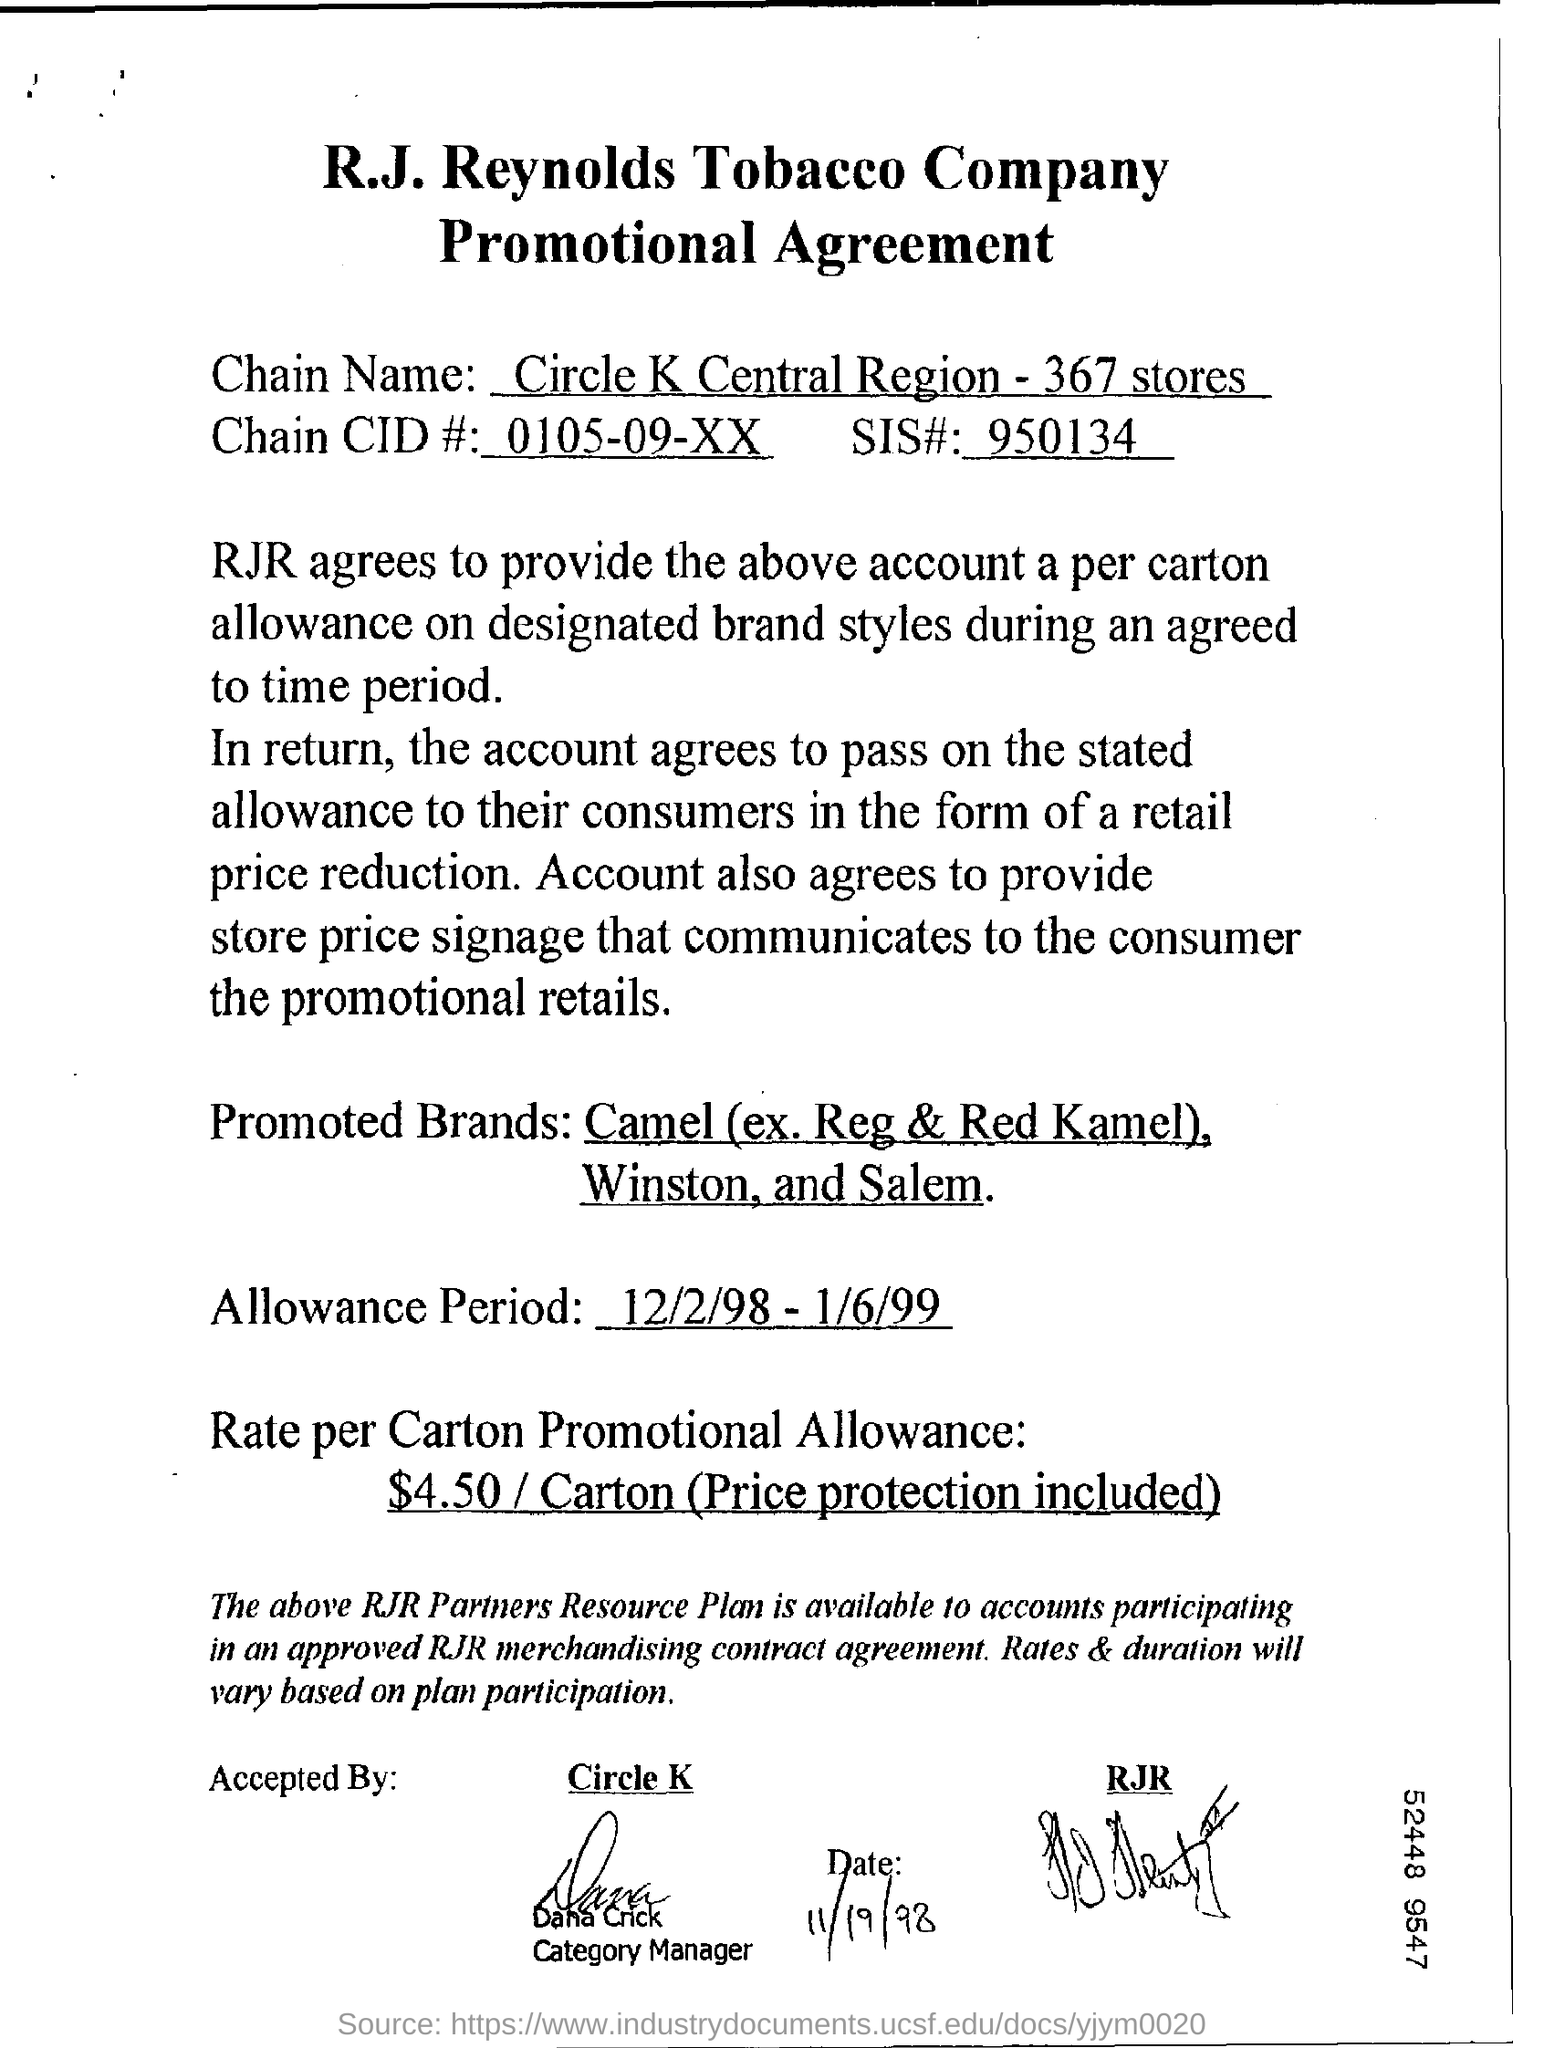what is the rate per carton promotional allowance?
 $4.50/ Carton (Price protection included) 